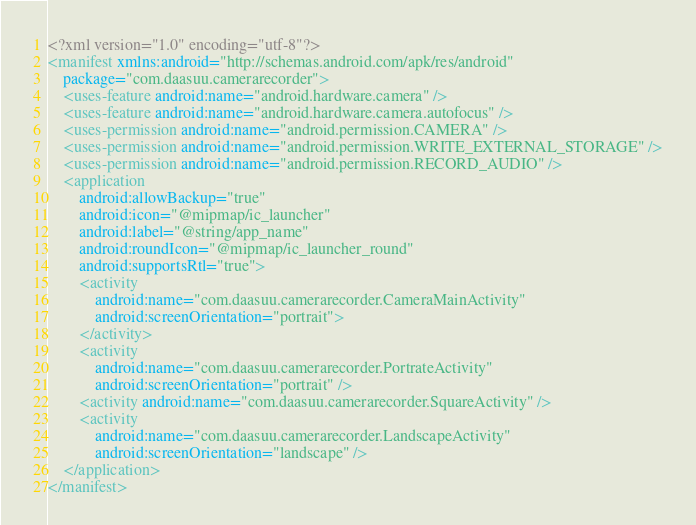<code> <loc_0><loc_0><loc_500><loc_500><_XML_><?xml version="1.0" encoding="utf-8"?>
<manifest xmlns:android="http://schemas.android.com/apk/res/android"
    package="com.daasuu.camerarecorder">
    <uses-feature android:name="android.hardware.camera" />
    <uses-feature android:name="android.hardware.camera.autofocus" />
    <uses-permission android:name="android.permission.CAMERA" />
    <uses-permission android:name="android.permission.WRITE_EXTERNAL_STORAGE" />
    <uses-permission android:name="android.permission.RECORD_AUDIO" />
    <application
        android:allowBackup="true"
        android:icon="@mipmap/ic_launcher"
        android:label="@string/app_name"
        android:roundIcon="@mipmap/ic_launcher_round"
        android:supportsRtl="true">
        <activity
            android:name="com.daasuu.camerarecorder.CameraMainActivity"
            android:screenOrientation="portrait">
        </activity>
        <activity
            android:name="com.daasuu.camerarecorder.PortrateActivity"
            android:screenOrientation="portrait" />
        <activity android:name="com.daasuu.camerarecorder.SquareActivity" />
        <activity
            android:name="com.daasuu.camerarecorder.LandscapeActivity"
            android:screenOrientation="landscape" />
    </application>
</manifest></code> 